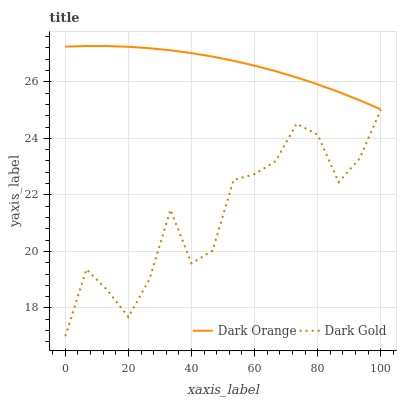Does Dark Gold have the maximum area under the curve?
Answer yes or no. No. Is Dark Gold the smoothest?
Answer yes or no. No. Does Dark Gold have the highest value?
Answer yes or no. No. Is Dark Gold less than Dark Orange?
Answer yes or no. Yes. Is Dark Orange greater than Dark Gold?
Answer yes or no. Yes. Does Dark Gold intersect Dark Orange?
Answer yes or no. No. 